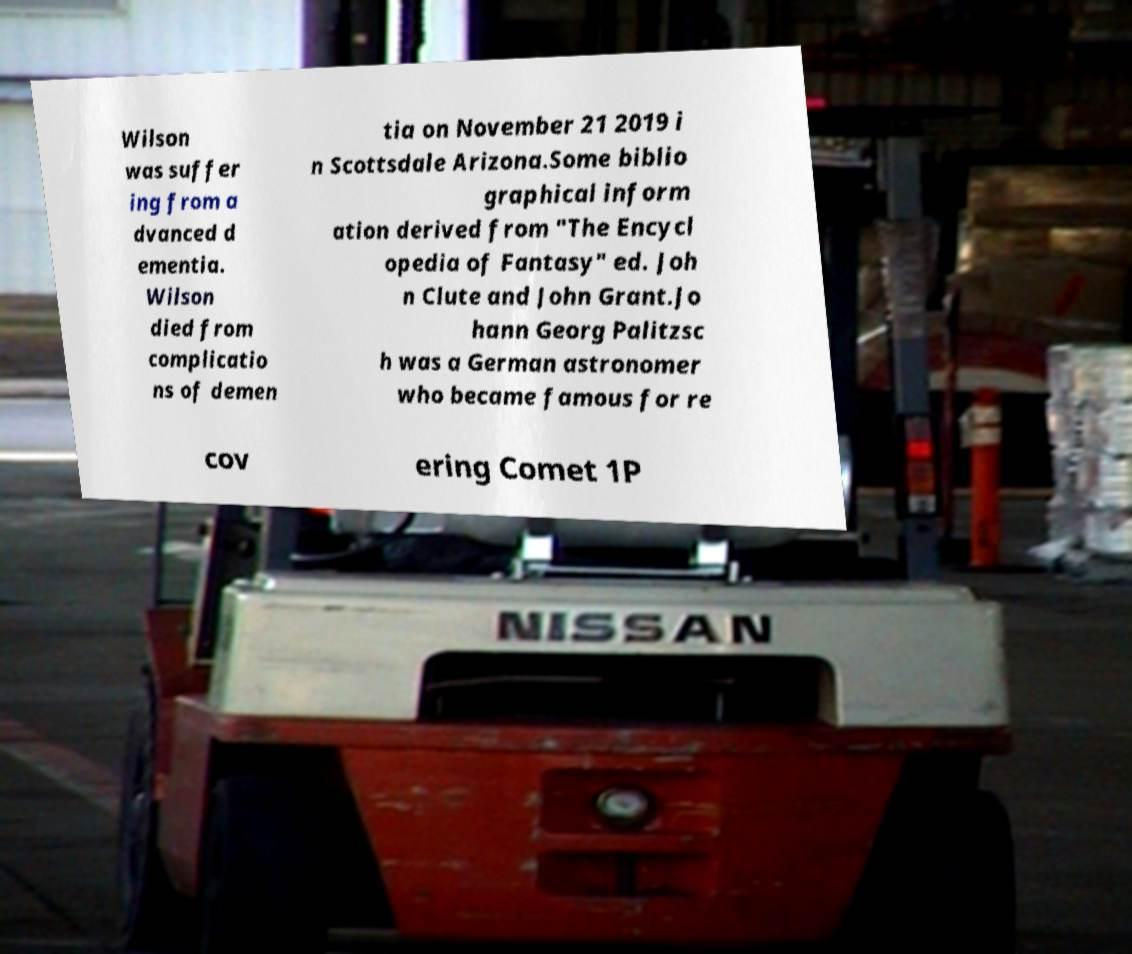For documentation purposes, I need the text within this image transcribed. Could you provide that? Wilson was suffer ing from a dvanced d ementia. Wilson died from complicatio ns of demen tia on November 21 2019 i n Scottsdale Arizona.Some biblio graphical inform ation derived from "The Encycl opedia of Fantasy" ed. Joh n Clute and John Grant.Jo hann Georg Palitzsc h was a German astronomer who became famous for re cov ering Comet 1P 